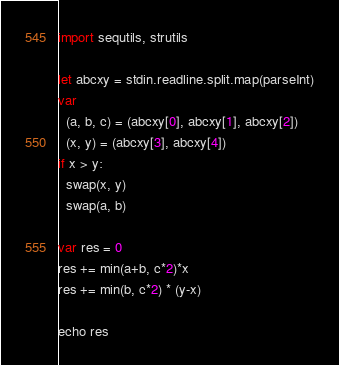Convert code to text. <code><loc_0><loc_0><loc_500><loc_500><_Nim_>import sequtils, strutils

let abcxy = stdin.readline.split.map(parseInt)
var
  (a, b, c) = (abcxy[0], abcxy[1], abcxy[2])
  (x, y) = (abcxy[3], abcxy[4])
if x > y:
  swap(x, y)
  swap(a, b)

var res = 0
res += min(a+b, c*2)*x
res += min(b, c*2) * (y-x)

echo res
</code> 